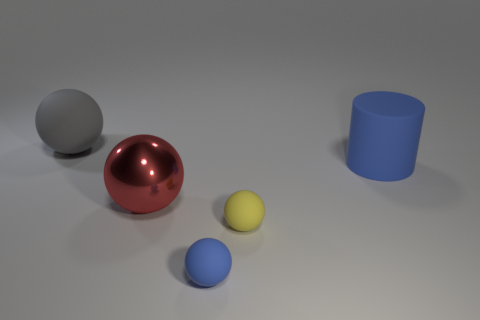Add 2 blue cylinders. How many objects exist? 7 Subtract all matte balls. How many balls are left? 1 Subtract all yellow balls. How many balls are left? 3 Subtract 1 cylinders. How many cylinders are left? 0 Subtract all brown spheres. How many red cylinders are left? 0 Subtract all tiny cyan cylinders. Subtract all red shiny objects. How many objects are left? 4 Add 2 tiny rubber spheres. How many tiny rubber spheres are left? 4 Add 3 big red matte cylinders. How many big red matte cylinders exist? 3 Subtract 0 yellow cubes. How many objects are left? 5 Subtract all cylinders. How many objects are left? 4 